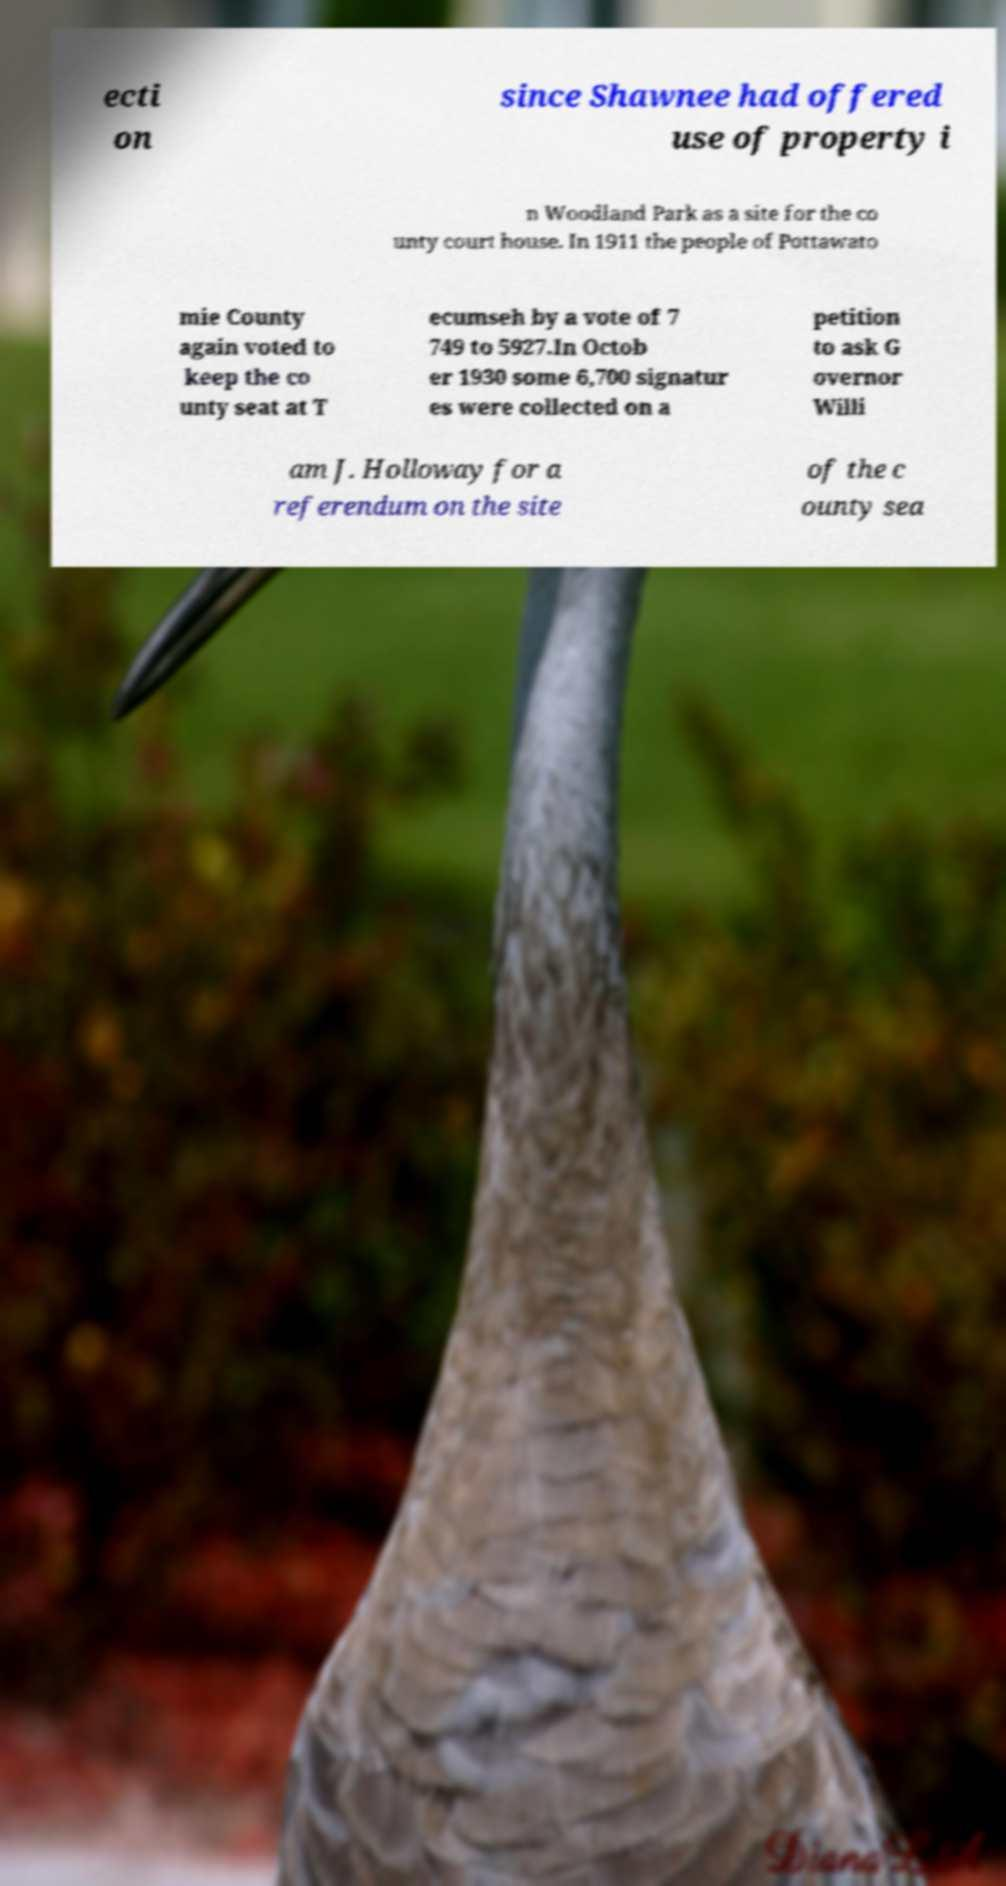Can you read and provide the text displayed in the image?This photo seems to have some interesting text. Can you extract and type it out for me? ecti on since Shawnee had offered use of property i n Woodland Park as a site for the co unty court house. In 1911 the people of Pottawato mie County again voted to keep the co unty seat at T ecumseh by a vote of 7 749 to 5927.In Octob er 1930 some 6,700 signatur es were collected on a petition to ask G overnor Willi am J. Holloway for a referendum on the site of the c ounty sea 